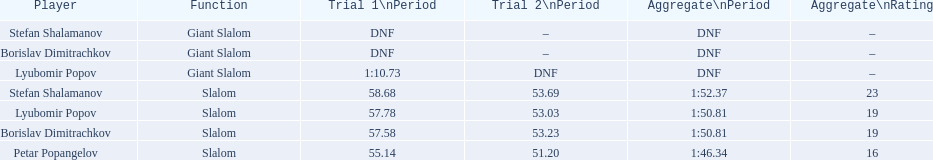What were the event names during bulgaria at the 1988 winter olympics? Stefan Shalamanov, Borislav Dimitrachkov, Lyubomir Popov. And which players participated at giant slalom? Giant Slalom, Giant Slalom, Giant Slalom, Slalom, Slalom, Slalom, Slalom. What were their race 1 times? DNF, DNF, 1:10.73. What was lyubomir popov's personal time? 1:10.73. 